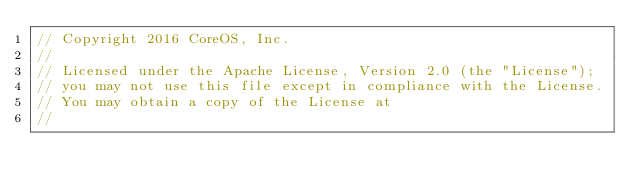Convert code to text. <code><loc_0><loc_0><loc_500><loc_500><_Go_>// Copyright 2016 CoreOS, Inc.
//
// Licensed under the Apache License, Version 2.0 (the "License");
// you may not use this file except in compliance with the License.
// You may obtain a copy of the License at
//</code> 